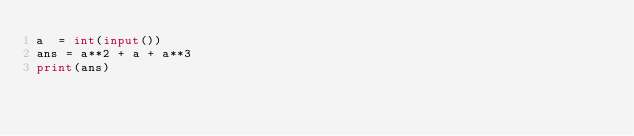Convert code to text. <code><loc_0><loc_0><loc_500><loc_500><_Python_>a  = int(input())
ans = a**2 + a + a**3
print(ans)</code> 